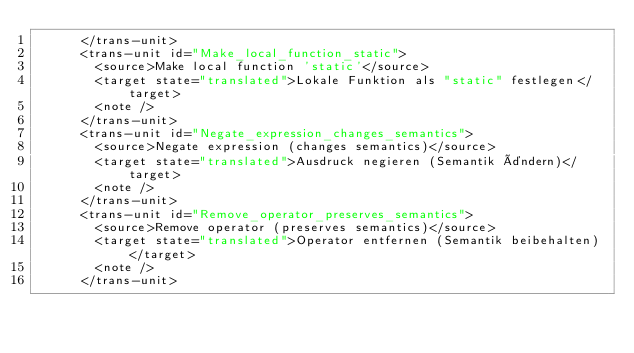<code> <loc_0><loc_0><loc_500><loc_500><_XML_>      </trans-unit>
      <trans-unit id="Make_local_function_static">
        <source>Make local function 'static'</source>
        <target state="translated">Lokale Funktion als "static" festlegen</target>
        <note />
      </trans-unit>
      <trans-unit id="Negate_expression_changes_semantics">
        <source>Negate expression (changes semantics)</source>
        <target state="translated">Ausdruck negieren (Semantik ändern)</target>
        <note />
      </trans-unit>
      <trans-unit id="Remove_operator_preserves_semantics">
        <source>Remove operator (preserves semantics)</source>
        <target state="translated">Operator entfernen (Semantik beibehalten)</target>
        <note />
      </trans-unit></code> 